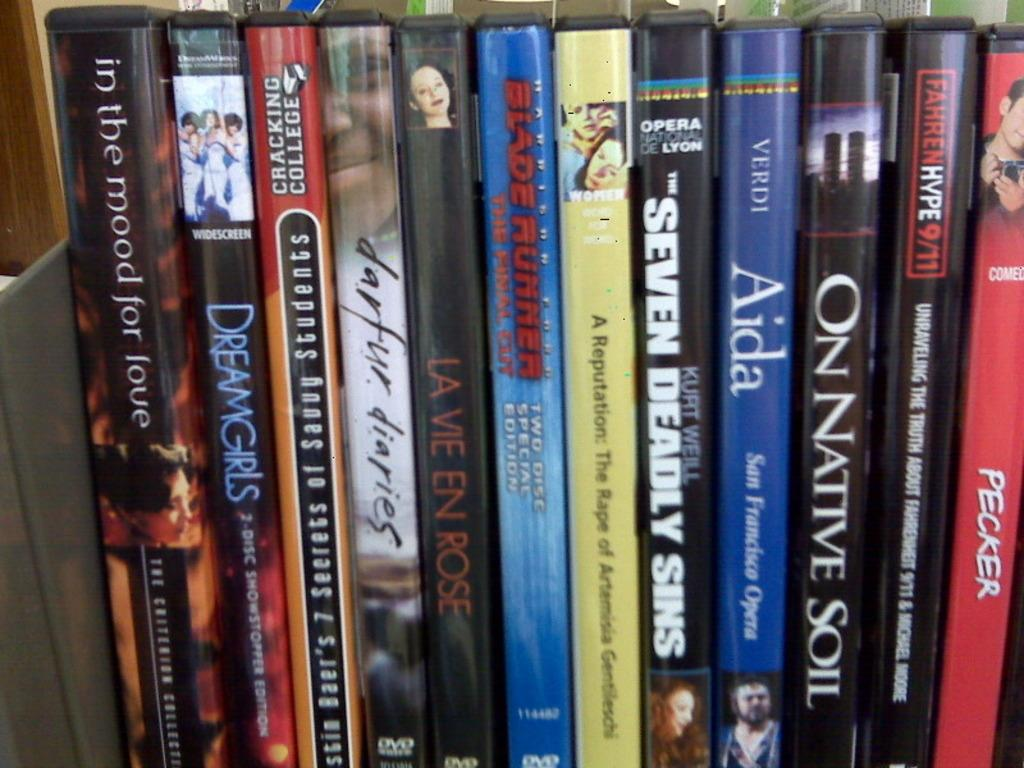<image>
Present a compact description of the photo's key features. Stack of films next to one another with "Seven Deadly Sins" in the middle. 